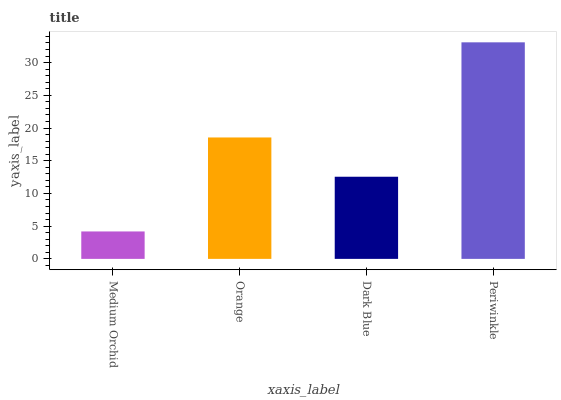Is Orange the minimum?
Answer yes or no. No. Is Orange the maximum?
Answer yes or no. No. Is Orange greater than Medium Orchid?
Answer yes or no. Yes. Is Medium Orchid less than Orange?
Answer yes or no. Yes. Is Medium Orchid greater than Orange?
Answer yes or no. No. Is Orange less than Medium Orchid?
Answer yes or no. No. Is Orange the high median?
Answer yes or no. Yes. Is Dark Blue the low median?
Answer yes or no. Yes. Is Dark Blue the high median?
Answer yes or no. No. Is Periwinkle the low median?
Answer yes or no. No. 